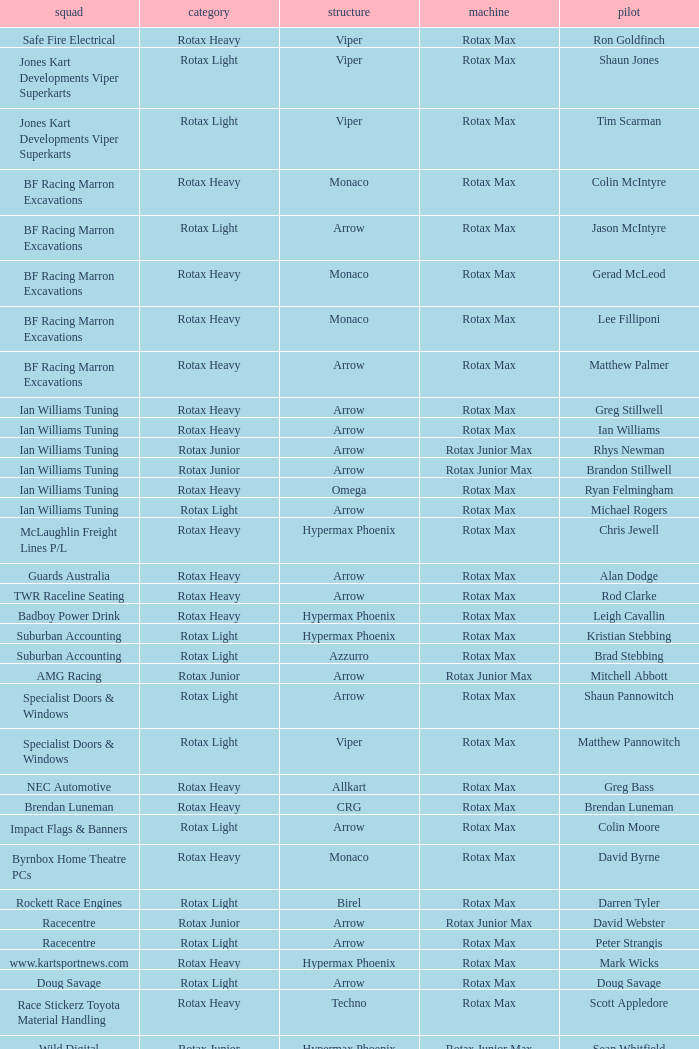What is the name of the driver with a rotax max engine, in the rotax heavy class, with arrow as chassis and on the TWR Raceline Seating team? Rod Clarke. 